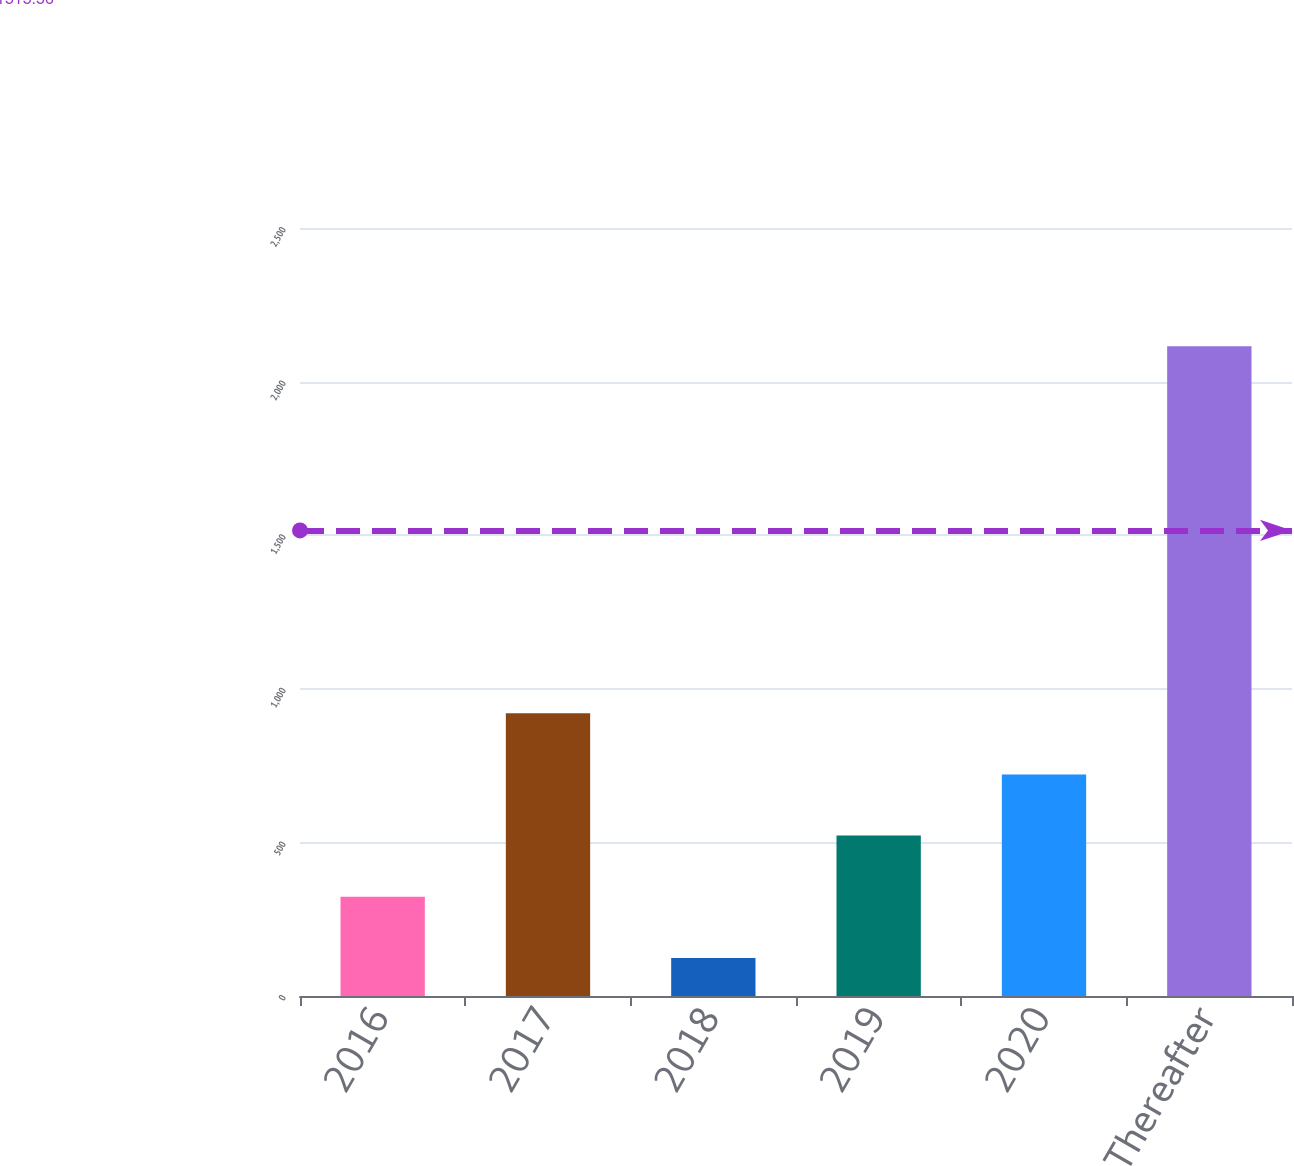Convert chart. <chart><loc_0><loc_0><loc_500><loc_500><bar_chart><fcel>2016<fcel>2017<fcel>2018<fcel>2019<fcel>2020<fcel>Thereafter<nl><fcel>323.1<fcel>920.4<fcel>124<fcel>522.2<fcel>721.3<fcel>2115<nl></chart> 